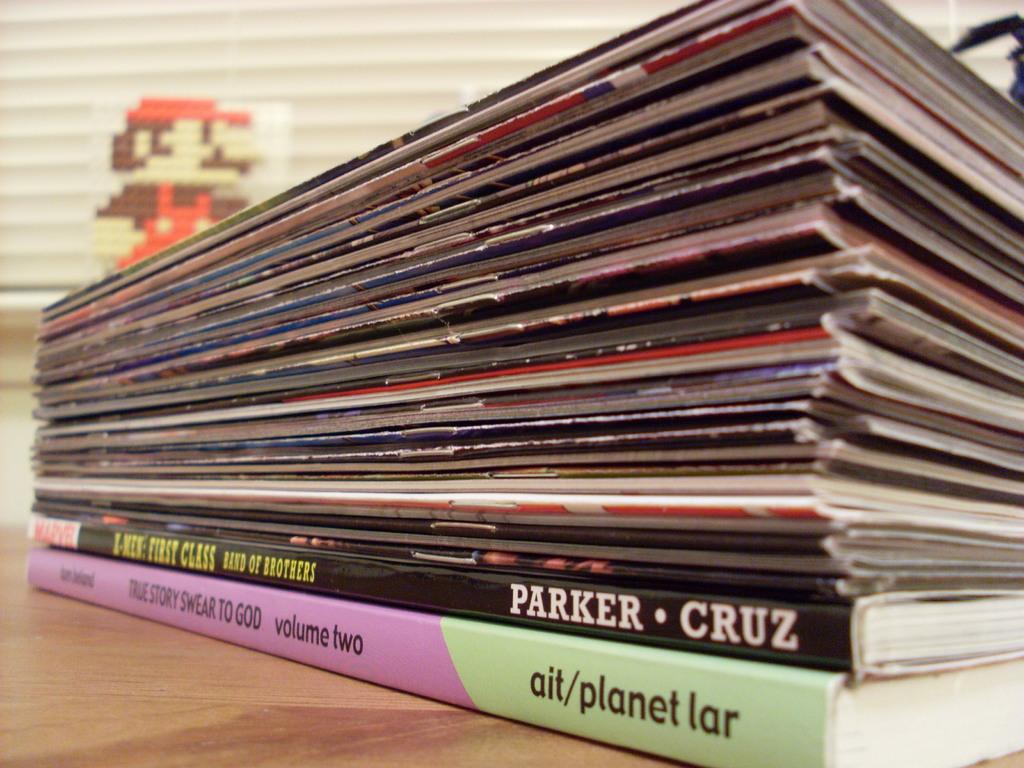What is the title of the book on the bottom of the pile?
Your answer should be compact. True story swear to god. 